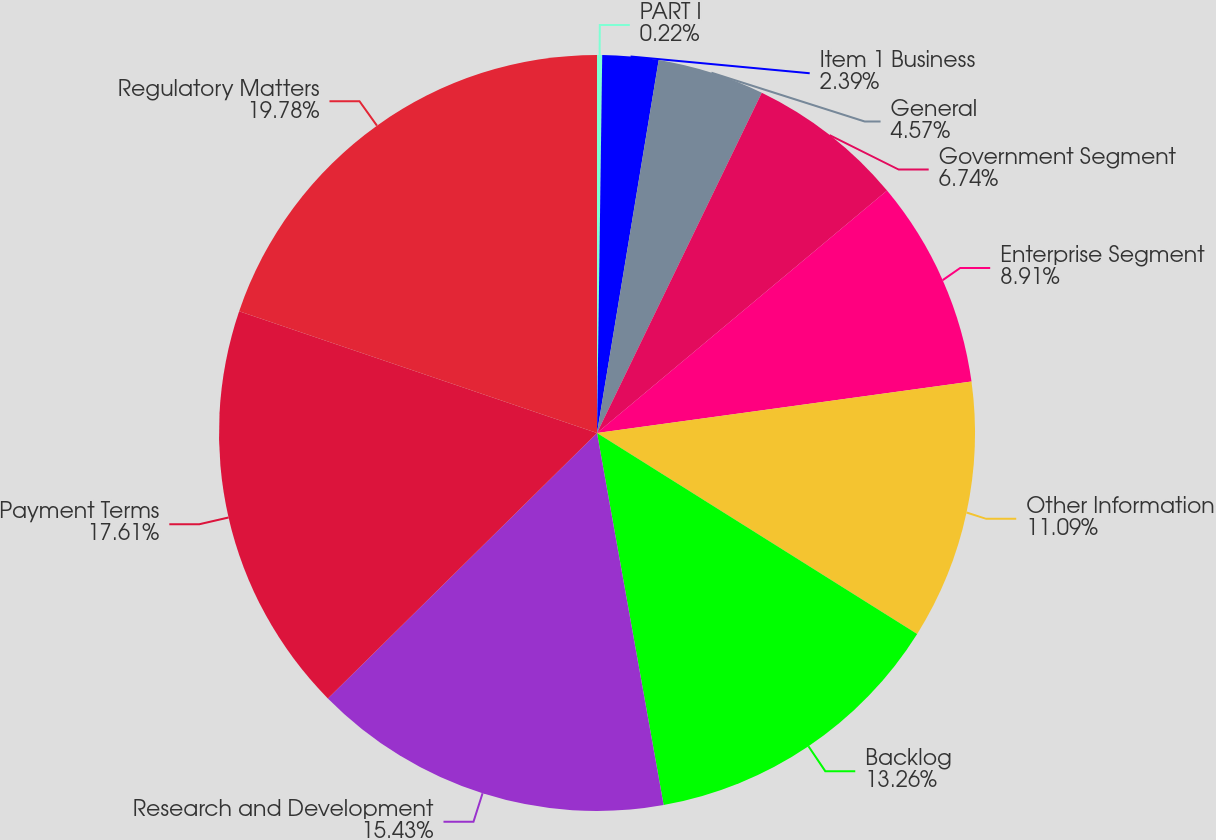Convert chart to OTSL. <chart><loc_0><loc_0><loc_500><loc_500><pie_chart><fcel>PART I<fcel>Item 1 Business<fcel>General<fcel>Government Segment<fcel>Enterprise Segment<fcel>Other Information<fcel>Backlog<fcel>Research and Development<fcel>Payment Terms<fcel>Regulatory Matters<nl><fcel>0.22%<fcel>2.39%<fcel>4.57%<fcel>6.74%<fcel>8.91%<fcel>11.09%<fcel>13.26%<fcel>15.43%<fcel>17.61%<fcel>19.78%<nl></chart> 